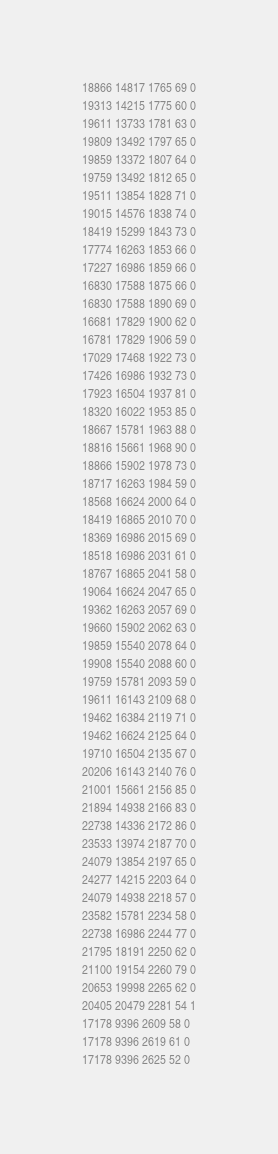<code> <loc_0><loc_0><loc_500><loc_500><_SML_>18866 14817 1765 69 0
19313 14215 1775 60 0
19611 13733 1781 63 0
19809 13492 1797 65 0
19859 13372 1807 64 0
19759 13492 1812 65 0
19511 13854 1828 71 0
19015 14576 1838 74 0
18419 15299 1843 73 0
17774 16263 1853 66 0
17227 16986 1859 66 0
16830 17588 1875 66 0
16830 17588 1890 69 0
16681 17829 1900 62 0
16781 17829 1906 59 0
17029 17468 1922 73 0
17426 16986 1932 73 0
17923 16504 1937 81 0
18320 16022 1953 85 0
18667 15781 1963 88 0
18816 15661 1968 90 0
18866 15902 1978 73 0
18717 16263 1984 59 0
18568 16624 2000 64 0
18419 16865 2010 70 0
18369 16986 2015 69 0
18518 16986 2031 61 0
18767 16865 2041 58 0
19064 16624 2047 65 0
19362 16263 2057 69 0
19660 15902 2062 63 0
19859 15540 2078 64 0
19908 15540 2088 60 0
19759 15781 2093 59 0
19611 16143 2109 68 0
19462 16384 2119 71 0
19462 16624 2125 64 0
19710 16504 2135 67 0
20206 16143 2140 76 0
21001 15661 2156 85 0
21894 14938 2166 83 0
22738 14336 2172 86 0
23533 13974 2187 70 0
24079 13854 2197 65 0
24277 14215 2203 64 0
24079 14938 2218 57 0
23582 15781 2234 58 0
22738 16986 2244 77 0
21795 18191 2250 62 0
21100 19154 2260 79 0
20653 19998 2265 62 0
20405 20479 2281 54 1
17178 9396 2609 58 0
17178 9396 2619 61 0
17178 9396 2625 52 0
</code> 